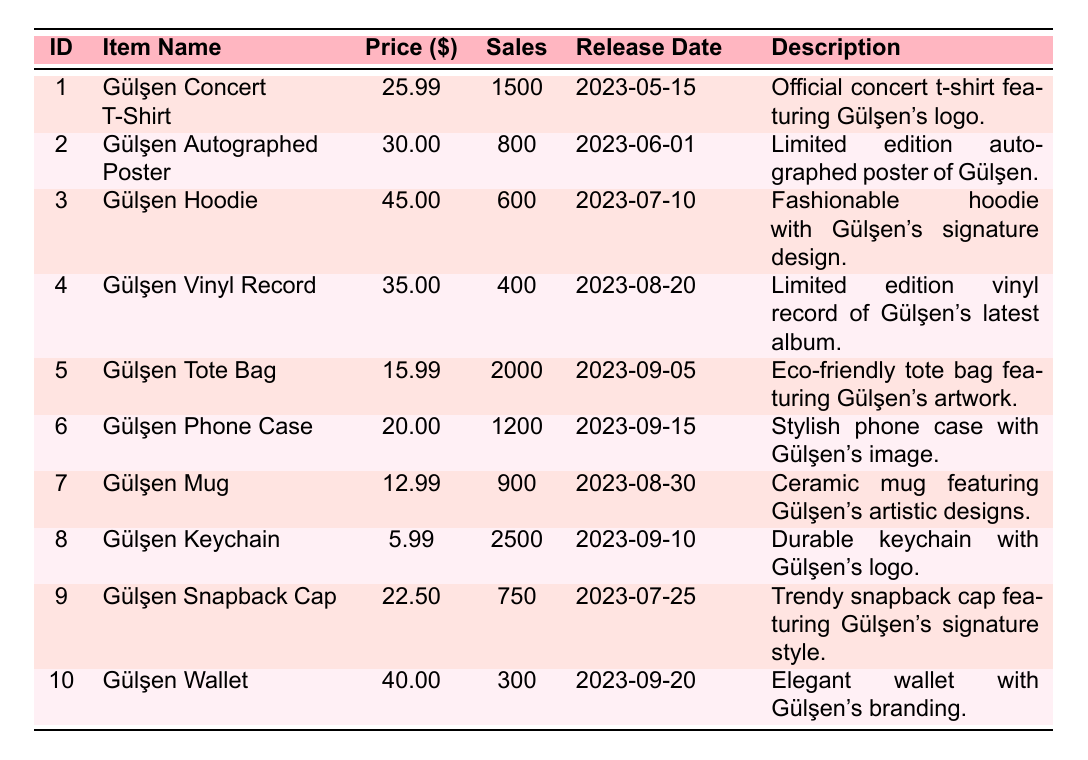What is the total sales volume of all merchandise items? To find the total sales volume, we add the sales volumes of all items listed in the table. The volumes are: 1500, 800, 600, 400, 2000, 1200, 900, 2500, 750, and 300. The total is calculated as 1500 + 800 + 600 + 400 + 2000 + 1200 + 900 + 2500 + 750 + 300 = 10150.
Answer: 10150 Which item has the highest price? The prices listed in the table are: 25.99, 30.00, 45.00, 35.00, 15.99, 20.00, 12.99, 5.99, 22.50, and 40.00. The highest price among these is 45.00, which corresponds to the item 'Gülşen Hoodie'.
Answer: Gülşen Hoodie Did more 'Apparel' items sell than 'Accessories' items? 'Apparel' items and their sales volumes are: Gülşen Concert T-Shirt (1500), Gülşen Hoodie (600), and Gülşen Snapback Cap (750), totaling 2850. For 'Accessories', the items are: Gülşen Tote Bag (2000), Gülşen Phone Case (1200), Gülşen Keychain (2500), and Gülşen Wallet (300), totaling 5000. Comparing both totals, 2850 is less than 5000.
Answer: No What is the average price of the merchandise in the table? We sum up all the prices: 25.99 + 30.00 + 45.00 + 35.00 + 15.99 + 20.00 + 12.99 + 5.99 + 22.50 + 40.00 =  1 ****38.46.** There are 10 items, so we divide the total price by the number of items: 138.46 / 10 = 13.846.
Answer: 13.846 Is the Gülşen Autographed Poster more expensive than the Gülşen Tote Bag? The price of the Gülşen Autographed Poster is 30.00, while the price of the Gülşen Tote Bag is 15.99. Since 30.00 is greater than 15.99, we conclude that the Gülşen Autographed Poster is indeed more expensive.
Answer: Yes How many items were released in August 2023, and what are they? The month of August has two items: Gülşen Vinyl Record released on 2023-08-20, and Gülşen Mug released on 2023-08-30. Counting these, there are two items released in August 2023.
Answer: 2 items: Gülşen Vinyl Record, Gülşen Mug What is the difference in sales volume between the best and worst-selling items? To find this, we identify the highest sales volume, which is the Gülşen Keychain at 2500, and the lowest, which is the Gülşen Wallet at 300. The difference is calculated as 2500 - 300 = 2200.
Answer: 2200 Which category has the least number of items listed? We analyze the categories: 'Apparel' has 3 items, 'Posters' has 1, 'Music' has 1, 'Accessories' has 4, and 'Home & Living' has 1. The categories with only 1 item—'Posters', 'Music', and 'Home & Living'—are the least represented.
Answer: Posters, Music, Home & Living 